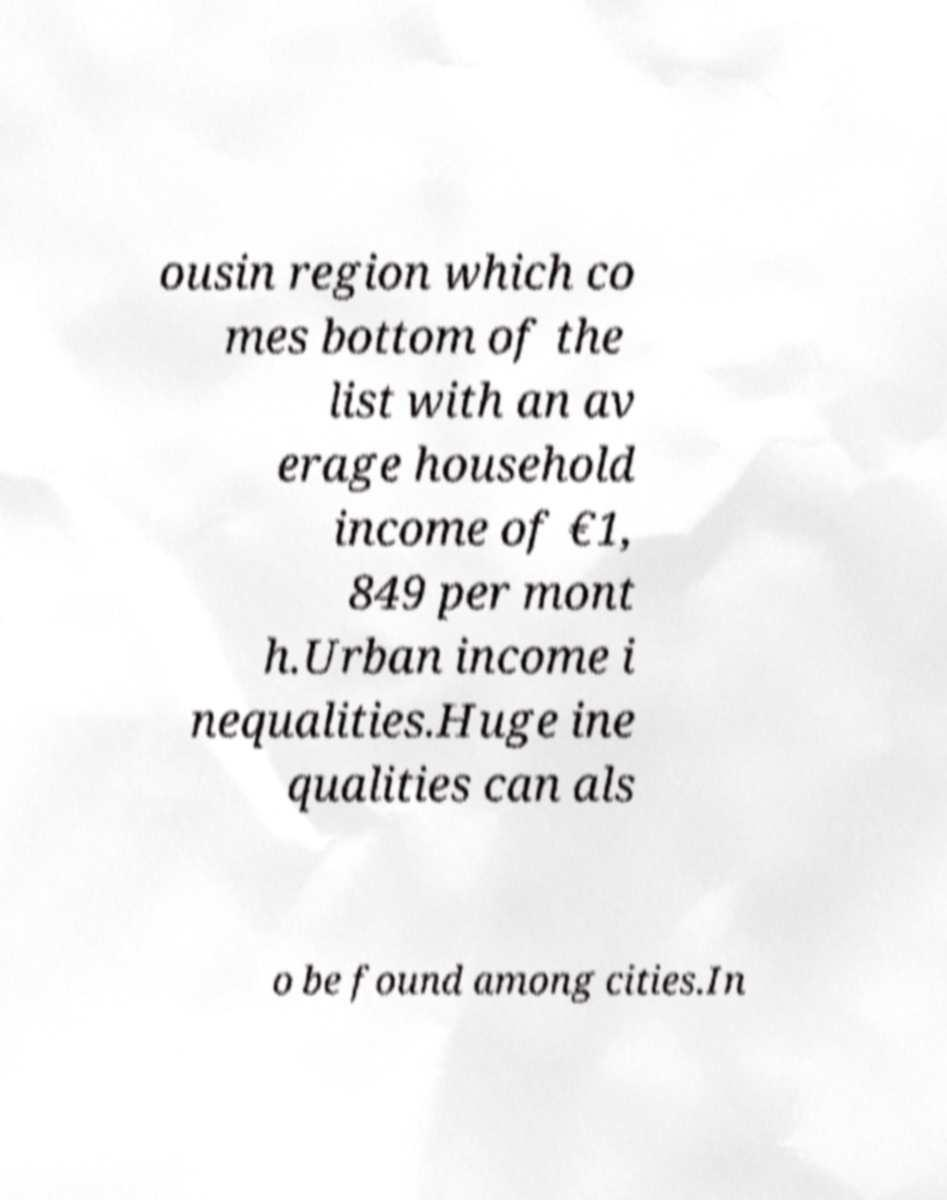I need the written content from this picture converted into text. Can you do that? ousin region which co mes bottom of the list with an av erage household income of €1, 849 per mont h.Urban income i nequalities.Huge ine qualities can als o be found among cities.In 